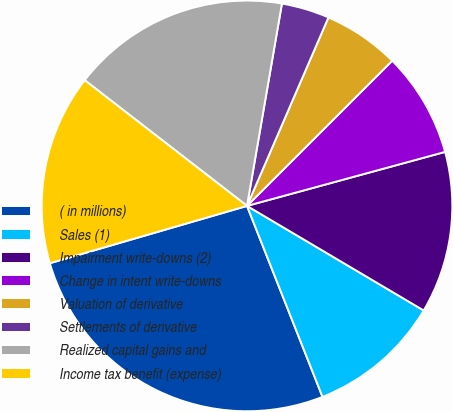Convert chart to OTSL. <chart><loc_0><loc_0><loc_500><loc_500><pie_chart><fcel>( in millions)<fcel>Sales (1)<fcel>Impairment write-downs (2)<fcel>Change in intent write-downs<fcel>Valuation of derivative<fcel>Settlements of derivative<fcel>Realized capital gains and<fcel>Income tax benefit (expense)<nl><fcel>26.49%<fcel>10.5%<fcel>12.74%<fcel>8.26%<fcel>6.01%<fcel>3.77%<fcel>17.23%<fcel>14.99%<nl></chart> 